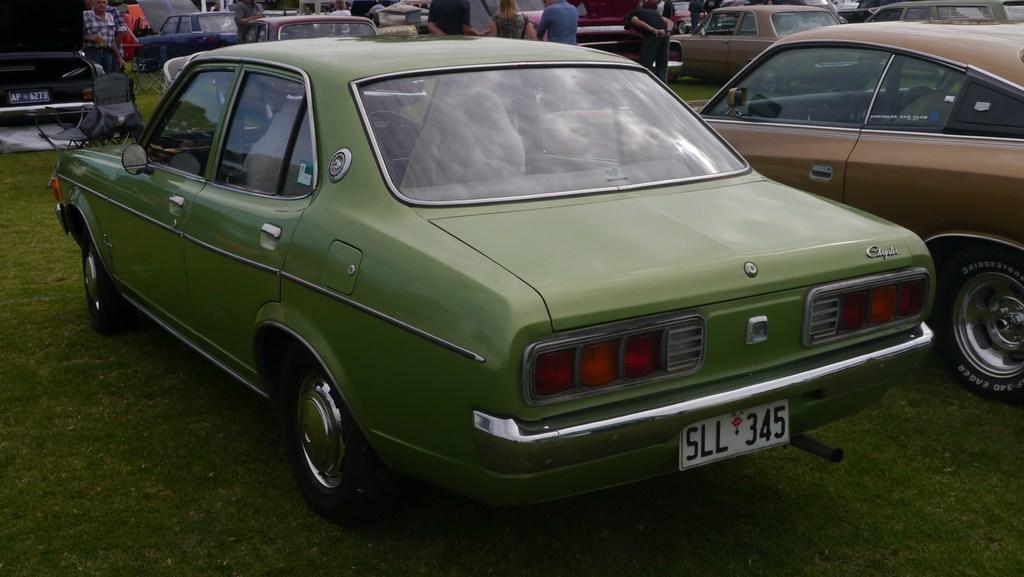In one or two sentences, can you explain what this image depicts? In the foreground of this image, there is a green colored car on the grass. In the background, there are cars, and persons standing on the grass and also a car on the right side of the image. 